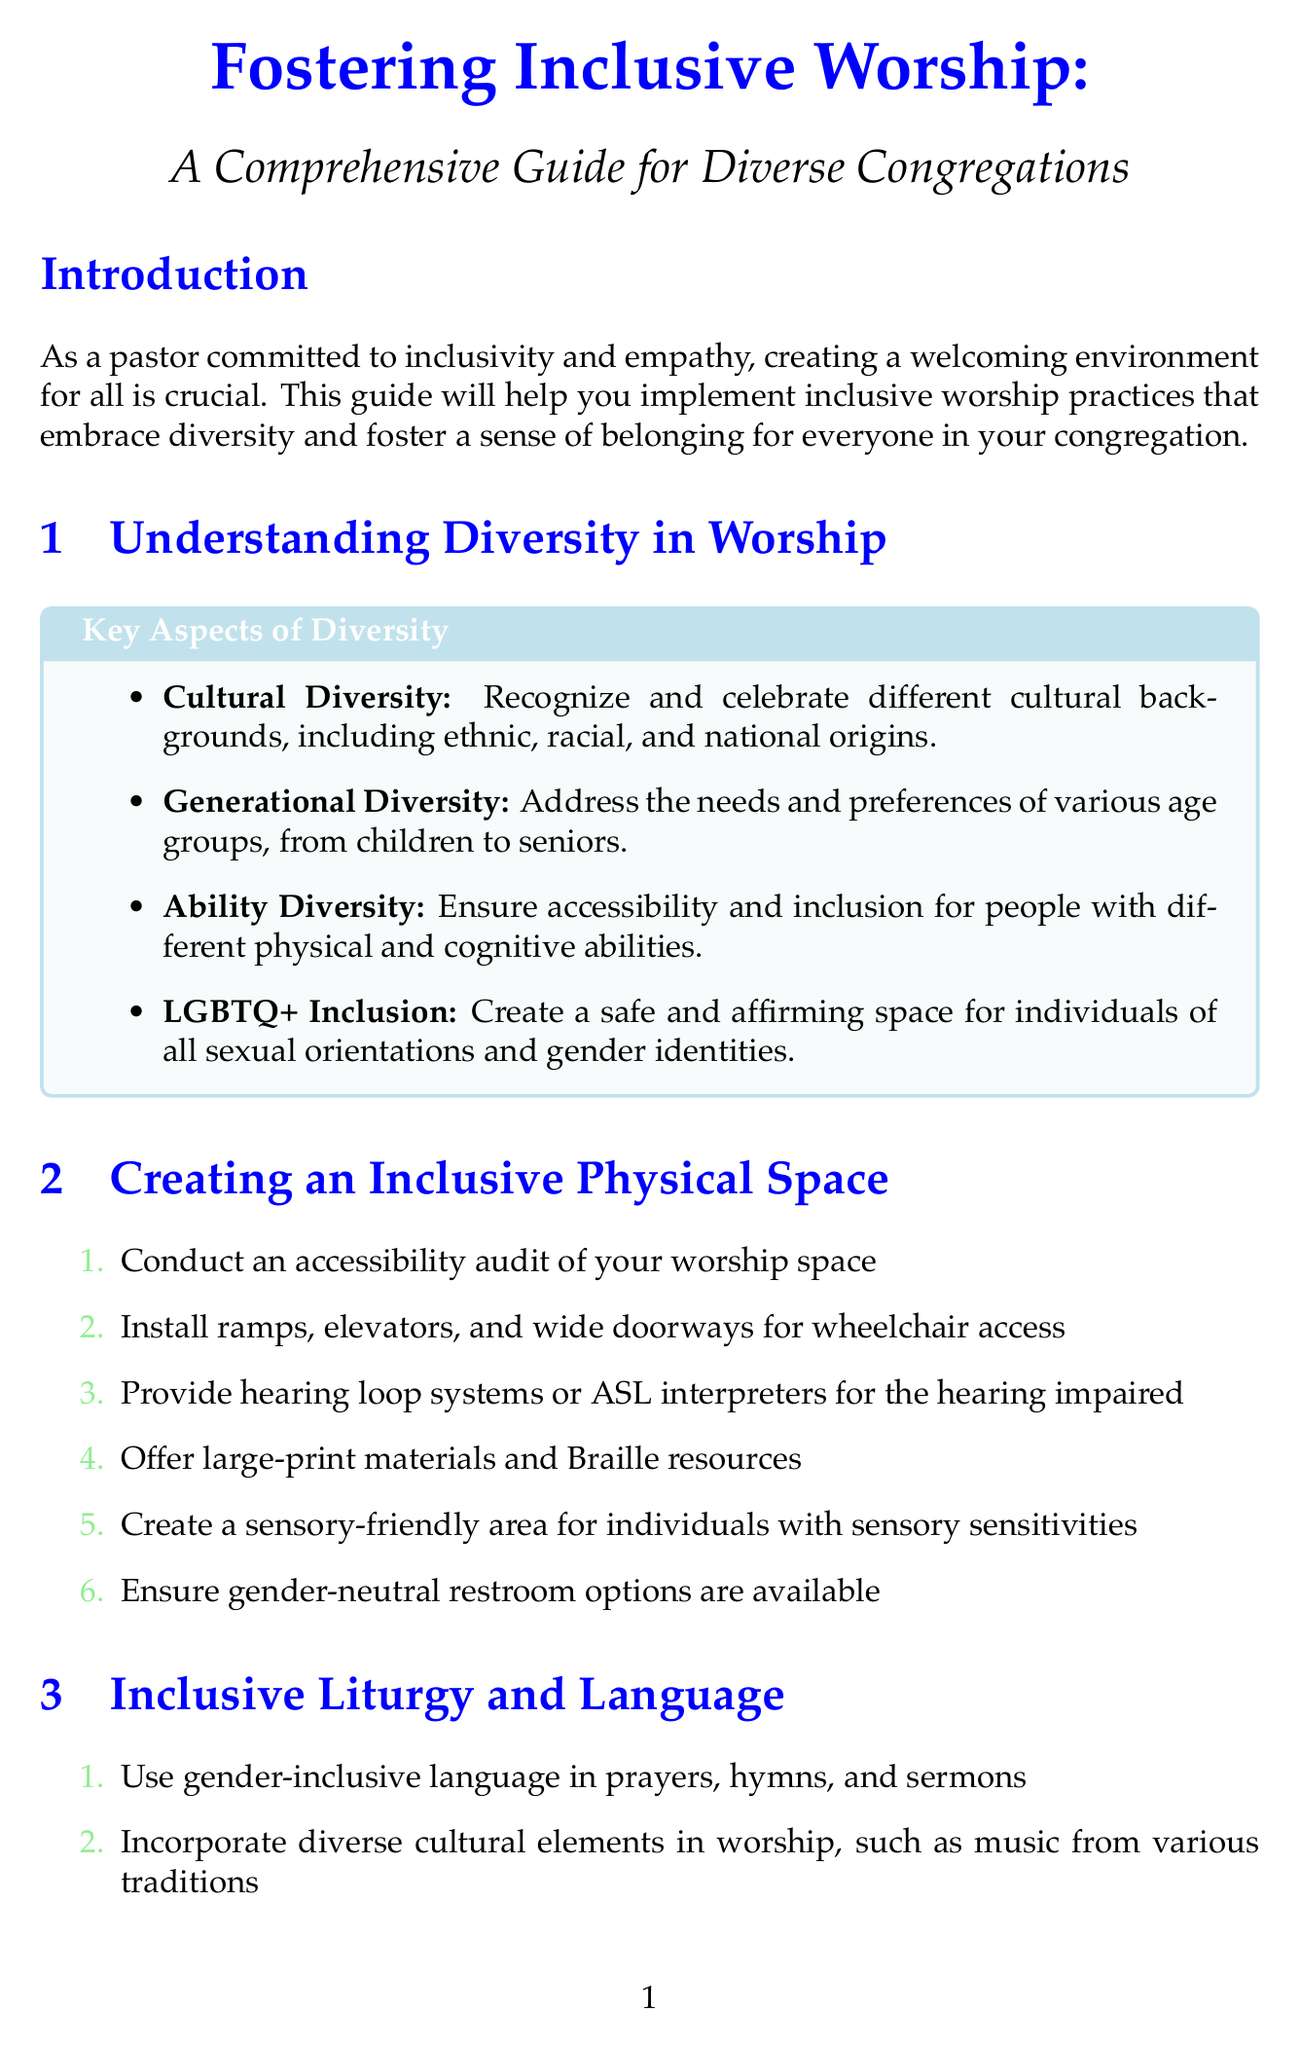What is the title of the guide? The title of the guide is stated clearly at the beginning of the document.
Answer: Fostering Inclusive Worship: A Comprehensive Guide for Diverse Congregations How many key aspects of diversity are listed? The number of key aspects of diversity can be counted from the section on understanding diversity in worship.
Answer: Four What is one tool mentioned for technology and inclusion? The tools for technology and inclusion are specifically listed in the document.
Answer: Live Streaming What step involves creating a sensory-friendly area? This step is part of creating an inclusive physical space, which includes specific tasks.
Answer: Creating a sensory-friendly area for individuals with sensory sensitivities What is the purpose of closed captioning? The purpose of closed captioning is described in the context of technology inclusion tools.
Answer: Provide real-time text for hearing-impaired individuals during services What does the Greeting Ministry strategy focus on? This strategy is detailed under building an inclusive community, addressing the approach to welcoming.
Answer: Warmly welcome all attendees What type of language should be used in prayers and hymns? This requirement is outlined in the section on inclusive liturgy and language.
Answer: Gender-inclusive language How often should surveys be conducted to assess inclusivity? This method is specified under measuring and improving inclusivity, indicating the frequency for surveys.
Answer: Regularly 